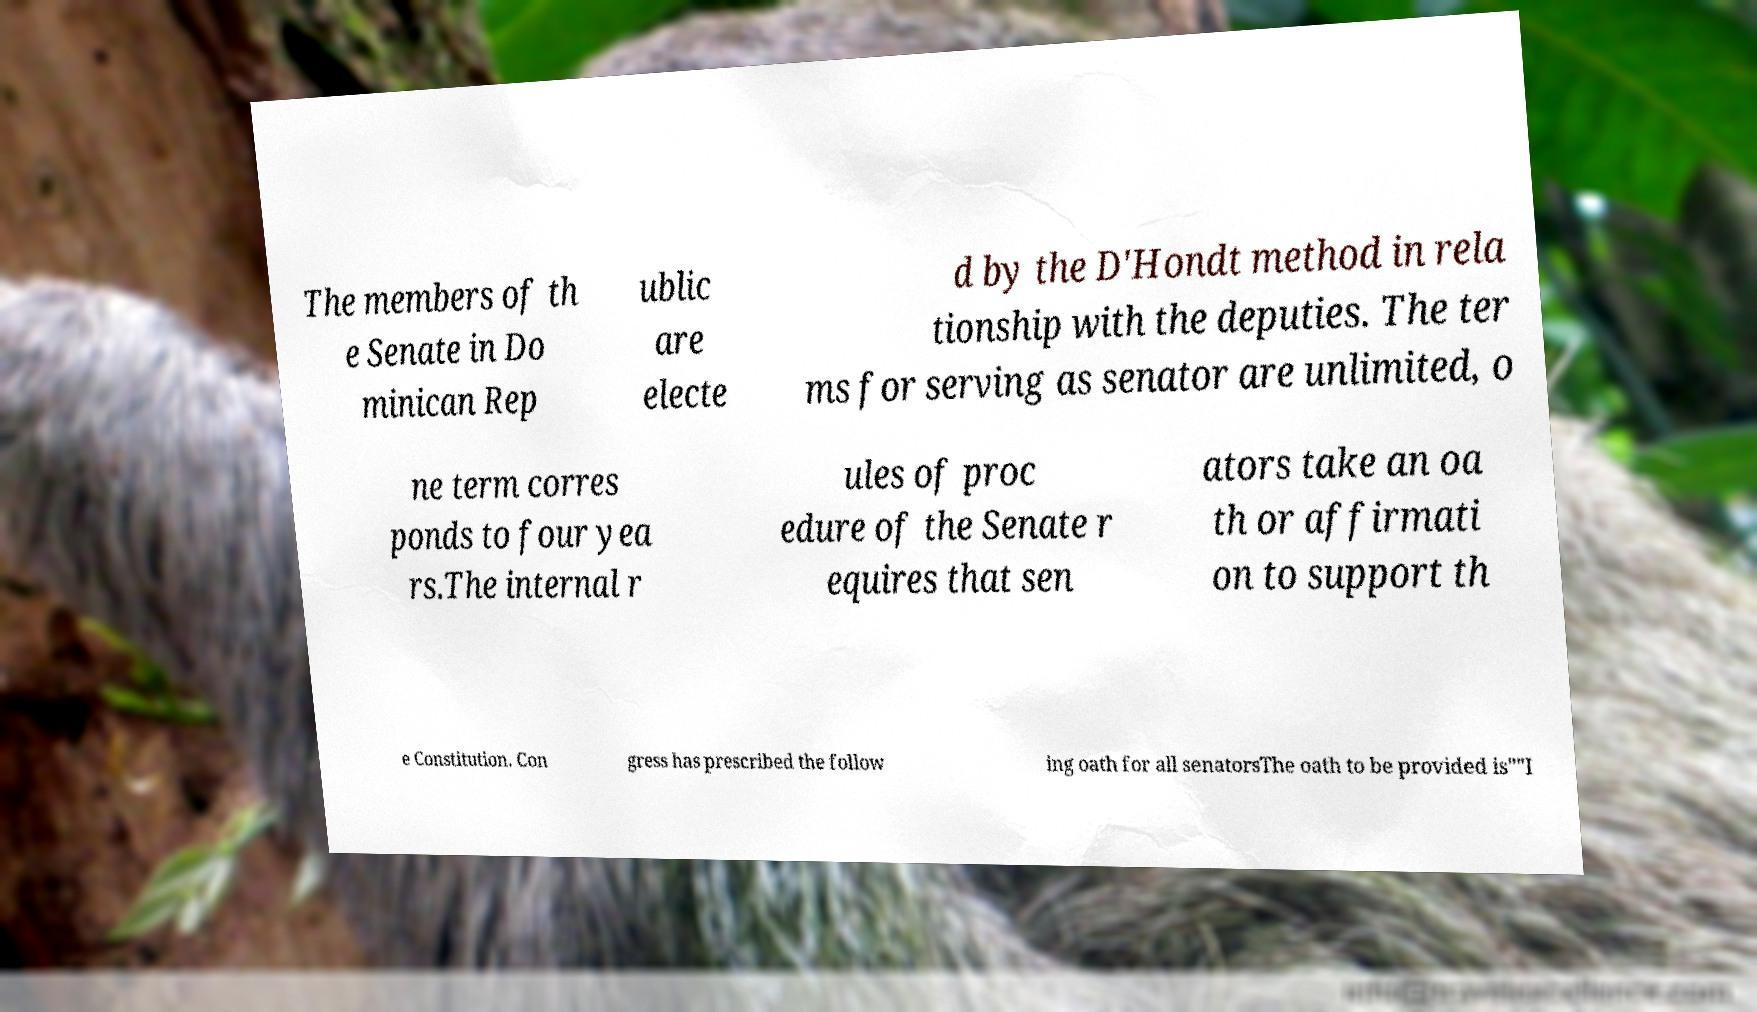Can you accurately transcribe the text from the provided image for me? The members of th e Senate in Do minican Rep ublic are electe d by the D'Hondt method in rela tionship with the deputies. The ter ms for serving as senator are unlimited, o ne term corres ponds to four yea rs.The internal r ules of proc edure of the Senate r equires that sen ators take an oa th or affirmati on to support th e Constitution. Con gress has prescribed the follow ing oath for all senatorsThe oath to be provided is""I 